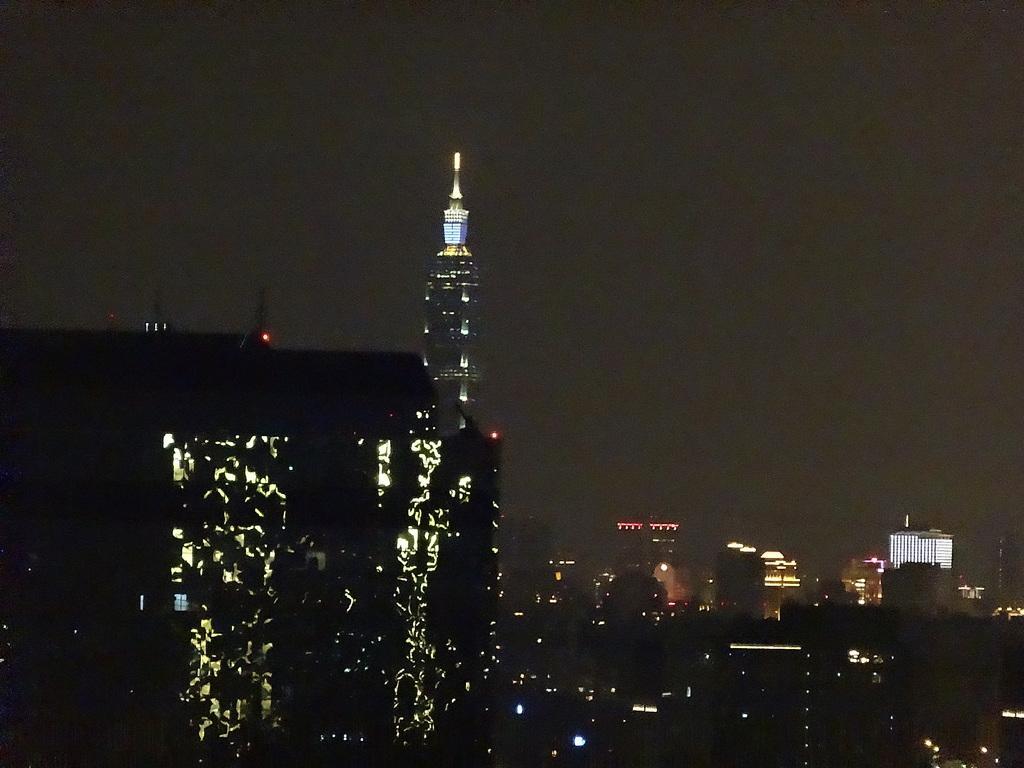Could you give a brief overview of what you see in this image? In this image we can see a group of buildings with lights. On the backside we can see the sky. 